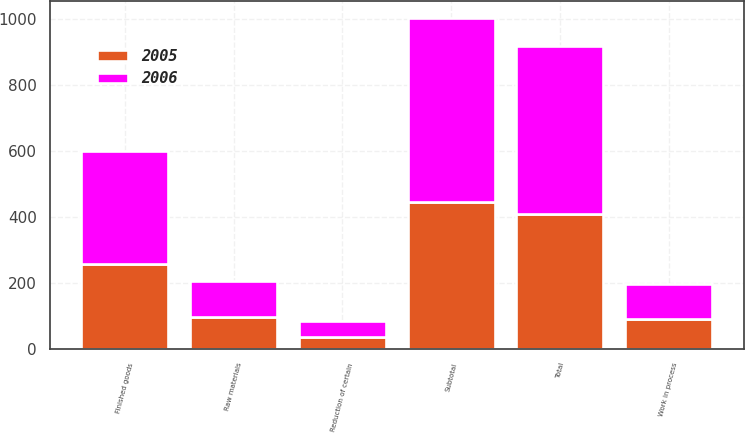Convert chart. <chart><loc_0><loc_0><loc_500><loc_500><stacked_bar_chart><ecel><fcel>Raw materials<fcel>Work in process<fcel>Finished goods<fcel>Subtotal<fcel>Reduction of certain<fcel>Total<nl><fcel>2006<fcel>108.7<fcel>107.7<fcel>341.7<fcel>558.1<fcel>48.7<fcel>509.4<nl><fcel>2005<fcel>97.9<fcel>90.1<fcel>256.7<fcel>444.7<fcel>35.6<fcel>409.1<nl></chart> 